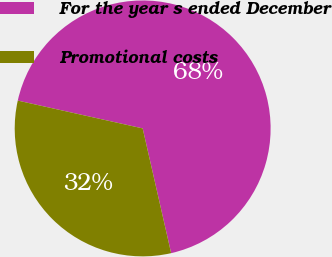Convert chart. <chart><loc_0><loc_0><loc_500><loc_500><pie_chart><fcel>For the year s ended December<fcel>Promotional costs<nl><fcel>67.94%<fcel>32.06%<nl></chart> 